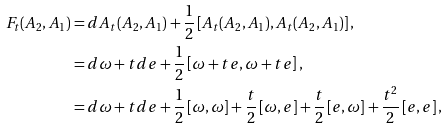Convert formula to latex. <formula><loc_0><loc_0><loc_500><loc_500>F _ { t } ( A _ { 2 } , A _ { 1 } ) & = d A _ { t } ( A _ { 2 } , A _ { 1 } ) + \frac { 1 } { 2 } \left [ A _ { t } ( A _ { 2 } , A _ { 1 } ) , A _ { t } ( A _ { 2 } , A _ { 1 } ) \right ] , \\ & = d \omega + t d e + \frac { 1 } { 2 } \left [ \omega + t e , \omega + t e \right ] , \\ & = d \omega + t d e + \frac { 1 } { 2 } \left [ \omega , \omega \right ] + \frac { t } { 2 } \left [ \omega , e \right ] + \frac { t } { 2 } \left [ e , \omega \right ] + \frac { t ^ { 2 } } { 2 } \left [ e , e \right ] ,</formula> 